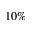<formula> <loc_0><loc_0><loc_500><loc_500>1 0 \%</formula> 